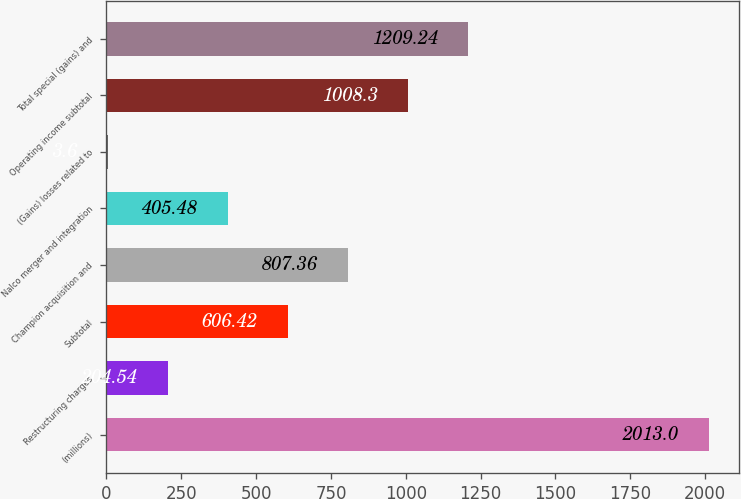Convert chart to OTSL. <chart><loc_0><loc_0><loc_500><loc_500><bar_chart><fcel>(millions)<fcel>Restructuring charges<fcel>Subtotal<fcel>Champion acquisition and<fcel>Nalco merger and integration<fcel>(Gains) losses related to<fcel>Operating income subtotal<fcel>Total special (gains) and<nl><fcel>2013<fcel>204.54<fcel>606.42<fcel>807.36<fcel>405.48<fcel>3.6<fcel>1008.3<fcel>1209.24<nl></chart> 